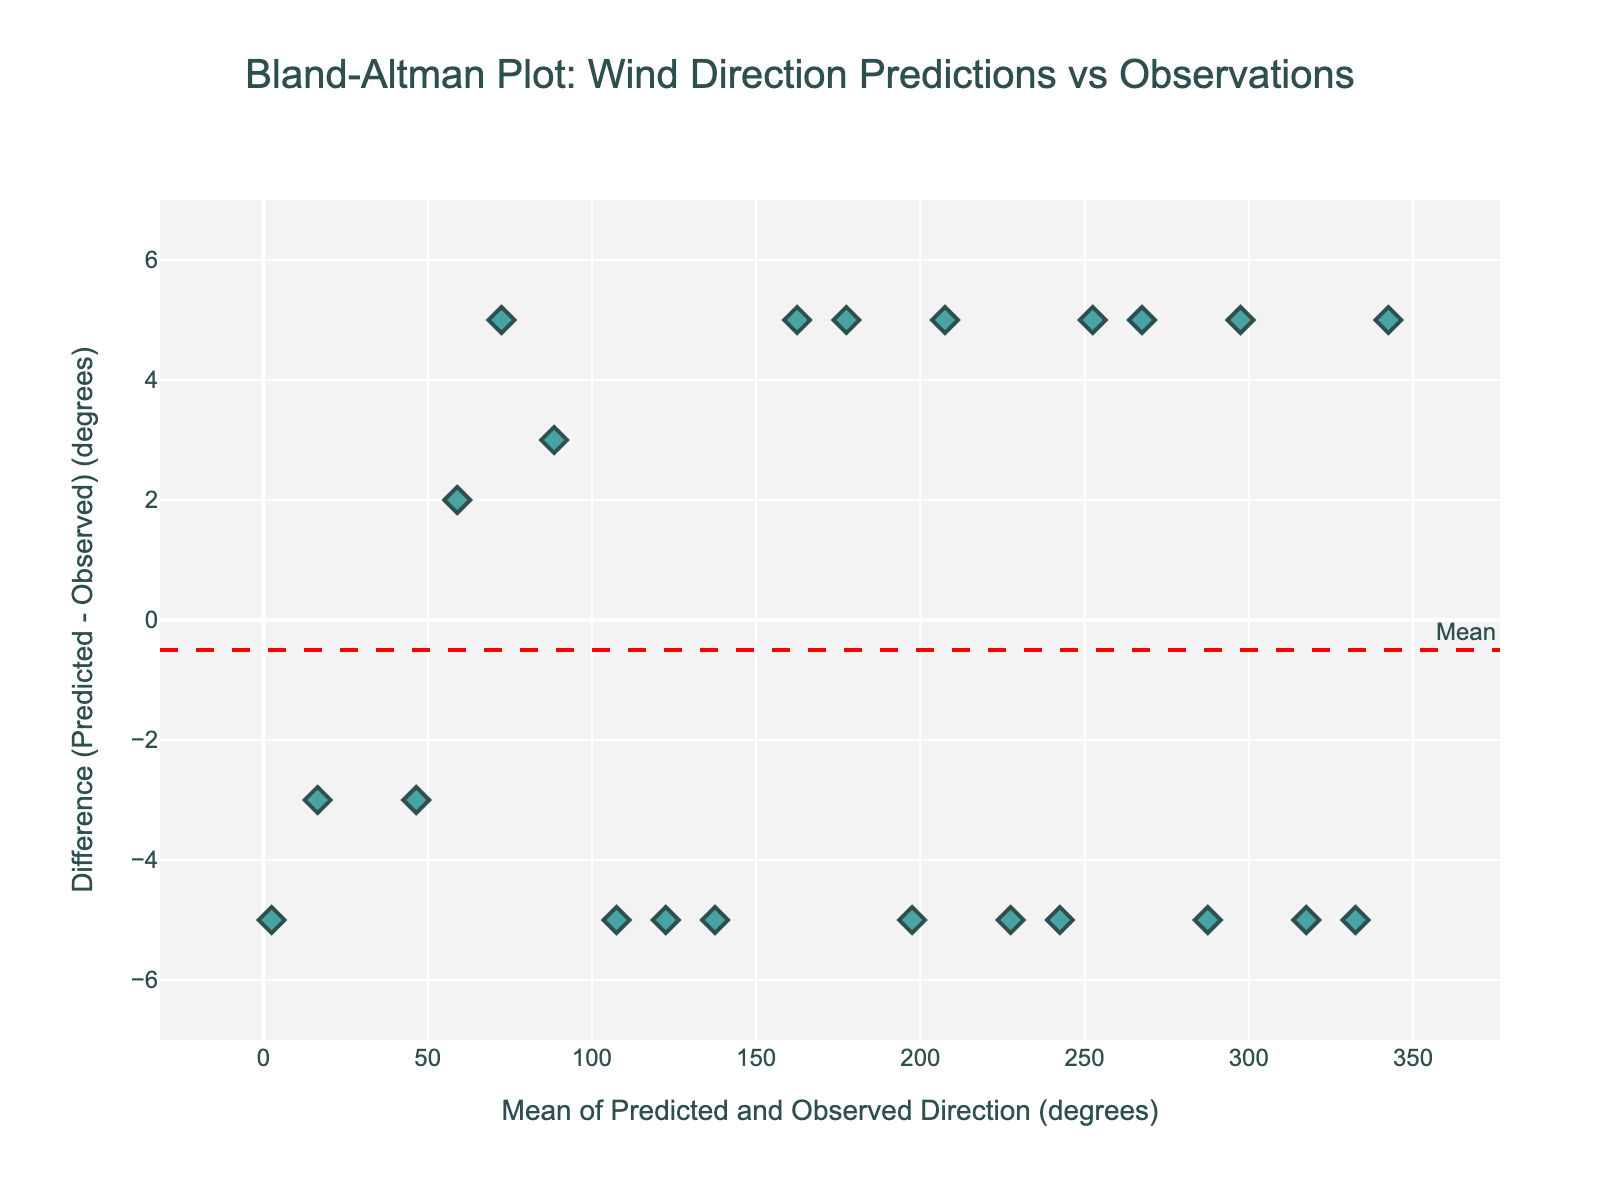What's the title of the plot? The title is typically placed at the top of the figure. In this case, it states "Bland-Altman Plot: Wind Direction Predictions vs Observations."
Answer: Bland-Altman Plot: Wind Direction Predictions vs Observations What does the x-axis represent? The x-axis label states "Mean of Predicted and Observed Direction (degrees)." This indicates the average value of the predicted and observed wind directions.
Answer: Mean of Predicted and Observed Direction (degrees) What is the range of the y-axis? The y-axis shows the "Difference (Predicted - Observed) (degrees)" and covers both positive and negative values. The exact range will be calculated from the data points, which show a range of differences approximately from -5 to +5 based on the visible scatter.
Answer: Approximately -5 to +5 degrees How many data points are plotted? The figure has 22 scattered markers, which can be seen as the individual points on the Bland-Altman plot.
Answer: 22 What is the color and shape of the data markers? The data markers are in the style of diamond shapes and colored in a translucent teal.
Answer: Teal diamond What is the mean difference, and how is it represented visually? The mean difference is shown with a dashed red horizontal line, labeled "Mean." This is the average of the differences between predicted and observed directions.
Answer: Dashed red line What are the upper and lower limits of agreement (LoA)? The upper and lower LoA are shown with dotted green lines, labeled "+1.96 SD" and "-1.96 SD," respectively. They represent the range within which most differences should lie, roughly calculated from the mean difference ± 1.96 times the standard deviation of the differences.
Answer: Dotted green lines at +1.96 SD and -1.96 SD What does a data point above the upper LoA signify? A data point above the upper LoA indicates a larger positive discrepancy between the predicted and observed directions than typically expected.
Answer: Larger positive discrepancy What can be inferred from data points consistently lying within the LoA? Data points consistently within the LoA indicate that the predictions and observations are in good agreement as most differences lie within expected bounds.
Answer: Good agreement Are there any outliers, and how are they identified? Outliers would be points that lie outside the limits of agreement. In this visualization, points outside the dashed green lines would be considered outliers, highlighting significant prediction errors.
Answer: Points outside the green lines 